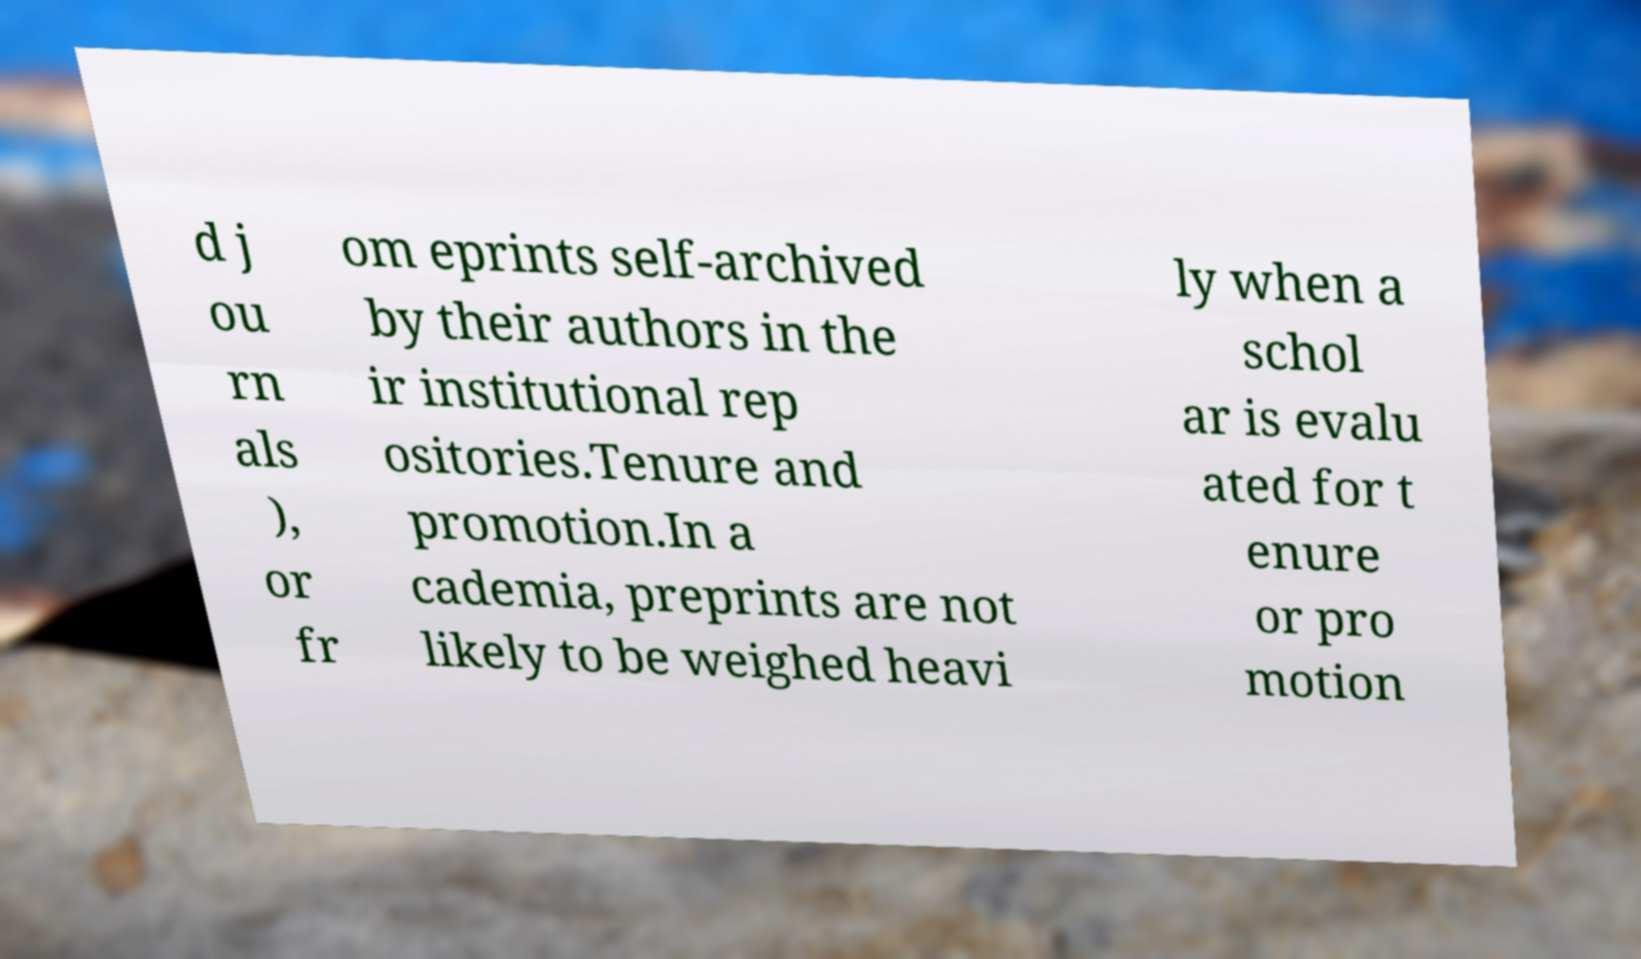Can you read and provide the text displayed in the image?This photo seems to have some interesting text. Can you extract and type it out for me? d j ou rn als ), or fr om eprints self-archived by their authors in the ir institutional rep ositories.Tenure and promotion.In a cademia, preprints are not likely to be weighed heavi ly when a schol ar is evalu ated for t enure or pro motion 